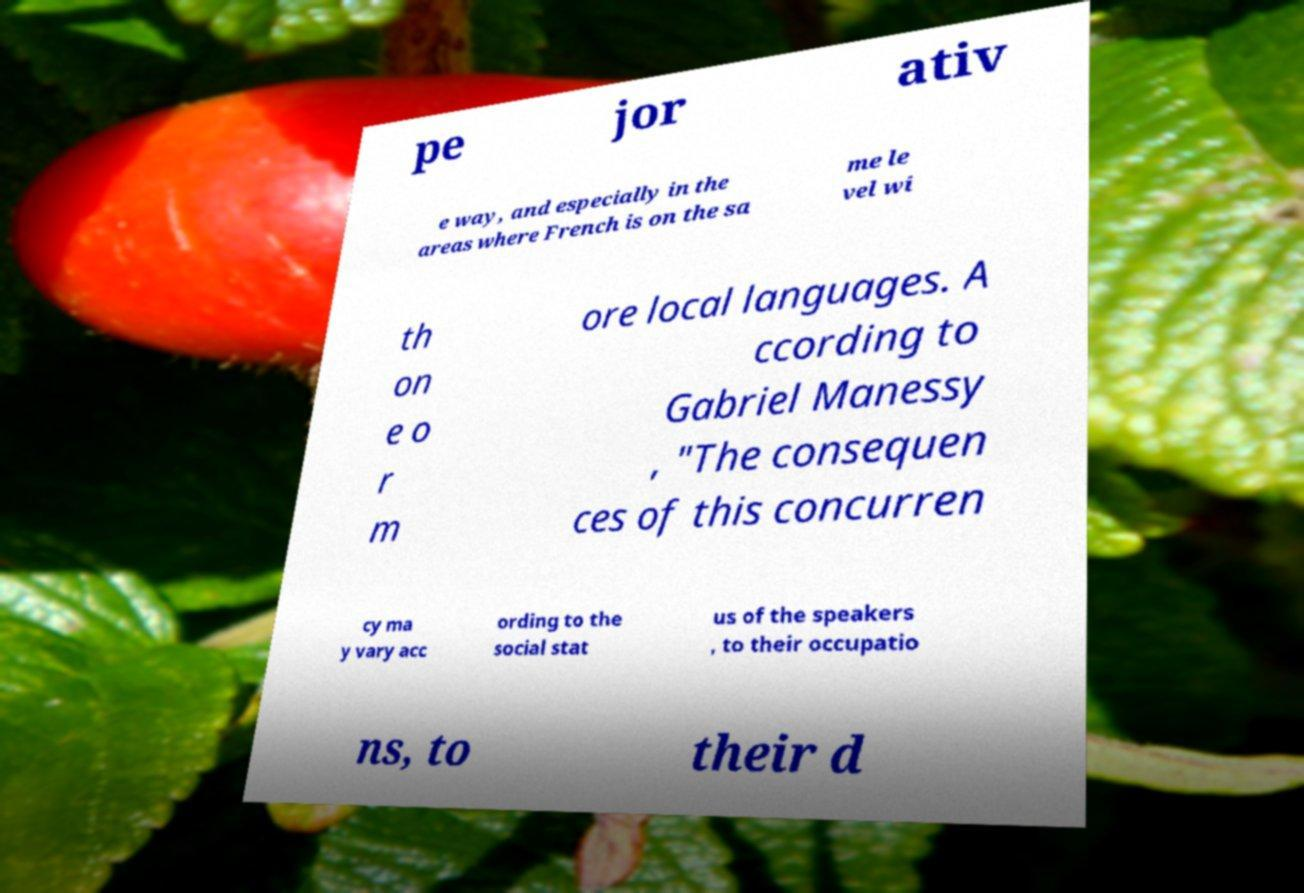What messages or text are displayed in this image? I need them in a readable, typed format. pe jor ativ e way, and especially in the areas where French is on the sa me le vel wi th on e o r m ore local languages. A ccording to Gabriel Manessy , "The consequen ces of this concurren cy ma y vary acc ording to the social stat us of the speakers , to their occupatio ns, to their d 